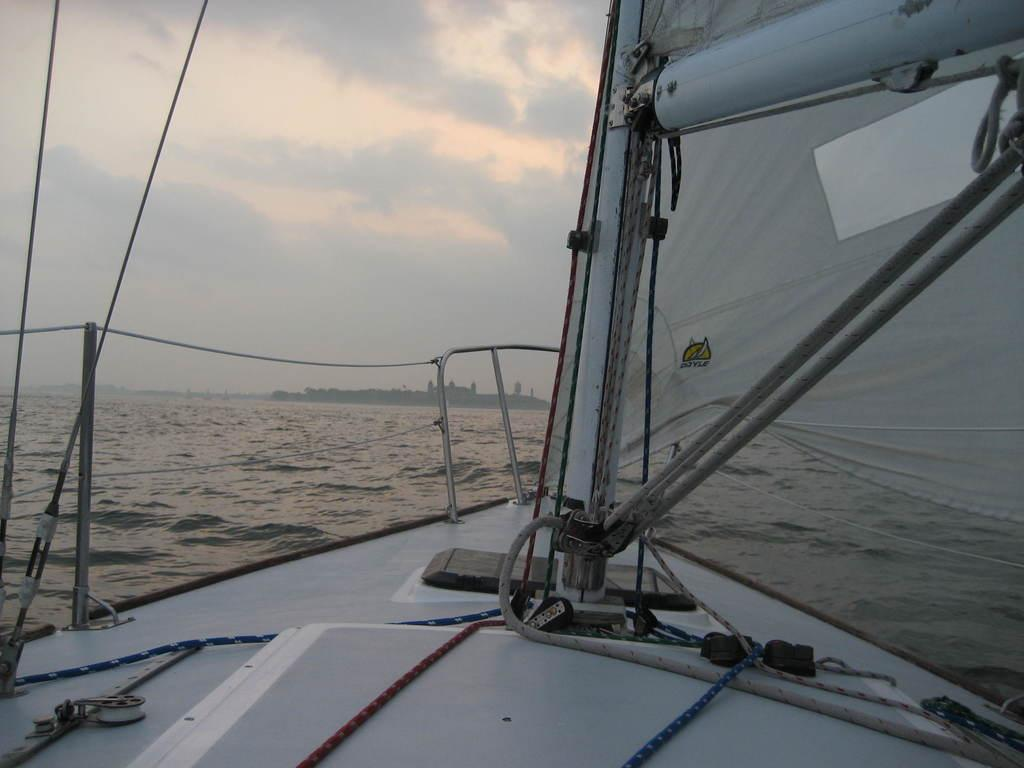What is the main subject of the image? The main subject of the image is a ship. Where is the ship located in the image? The ship is in the water. What can be seen in the background of the image? There are trees, at least one building, and the sky visible in the background of the image. What type of stew is being cooked on the ship in the image? There is no indication of any cooking or stew in the image; it only features a ship in the water with a background of trees, a building, and the sky. 